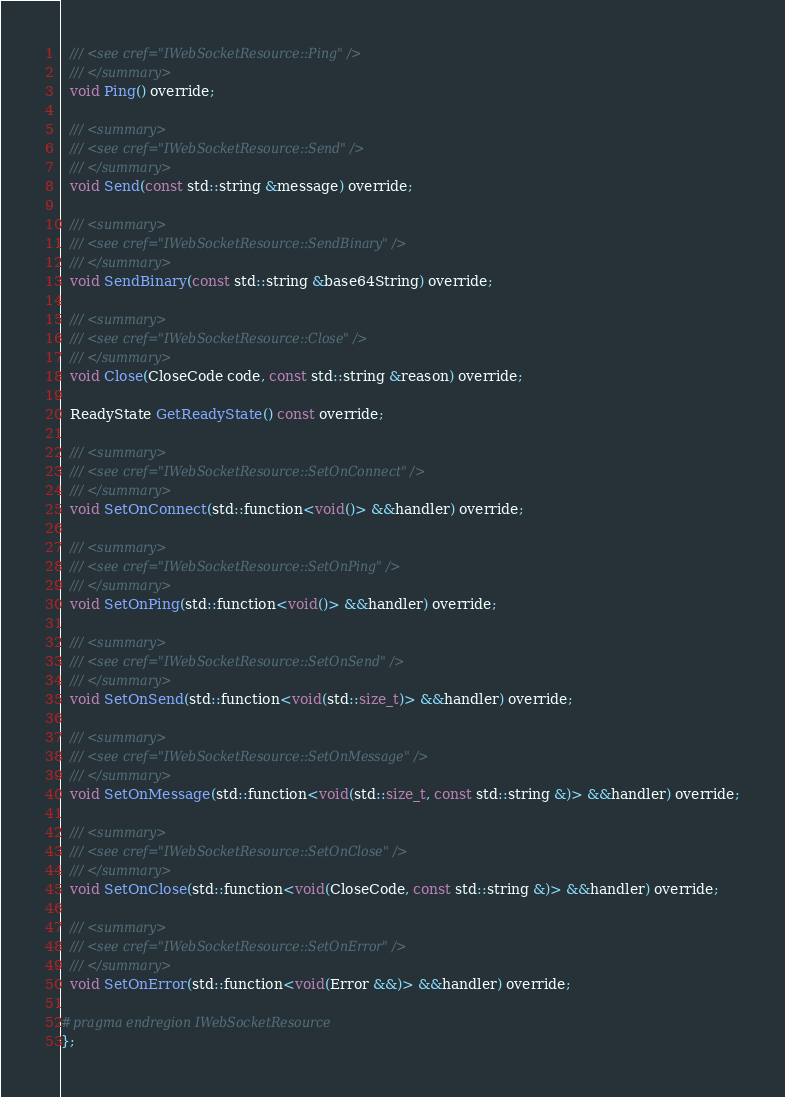<code> <loc_0><loc_0><loc_500><loc_500><_C_>  /// <see cref="IWebSocketResource::Ping" />
  /// </summary>
  void Ping() override;

  /// <summary>
  /// <see cref="IWebSocketResource::Send" />
  /// </summary>
  void Send(const std::string &message) override;

  /// <summary>
  /// <see cref="IWebSocketResource::SendBinary" />
  /// </summary>
  void SendBinary(const std::string &base64String) override;

  /// <summary>
  /// <see cref="IWebSocketResource::Close" />
  /// </summary>
  void Close(CloseCode code, const std::string &reason) override;

  ReadyState GetReadyState() const override;

  /// <summary>
  /// <see cref="IWebSocketResource::SetOnConnect" />
  /// </summary>
  void SetOnConnect(std::function<void()> &&handler) override;

  /// <summary>
  /// <see cref="IWebSocketResource::SetOnPing" />
  /// </summary>
  void SetOnPing(std::function<void()> &&handler) override;

  /// <summary>
  /// <see cref="IWebSocketResource::SetOnSend" />
  /// </summary>
  void SetOnSend(std::function<void(std::size_t)> &&handler) override;

  /// <summary>
  /// <see cref="IWebSocketResource::SetOnMessage" />
  /// </summary>
  void SetOnMessage(std::function<void(std::size_t, const std::string &)> &&handler) override;

  /// <summary>
  /// <see cref="IWebSocketResource::SetOnClose" />
  /// </summary>
  void SetOnClose(std::function<void(CloseCode, const std::string &)> &&handler) override;

  /// <summary>
  /// <see cref="IWebSocketResource::SetOnError" />
  /// </summary>
  void SetOnError(std::function<void(Error &&)> &&handler) override;

#pragma endregion IWebSocketResource
};
</code> 